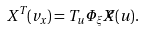<formula> <loc_0><loc_0><loc_500><loc_500>X ^ { T } ( v _ { x } ) = T _ { u } \Phi _ { \xi } \widetilde { X } ( u ) .</formula> 